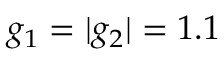Convert formula to latex. <formula><loc_0><loc_0><loc_500><loc_500>g _ { 1 } = | g _ { 2 } | = 1 . 1</formula> 